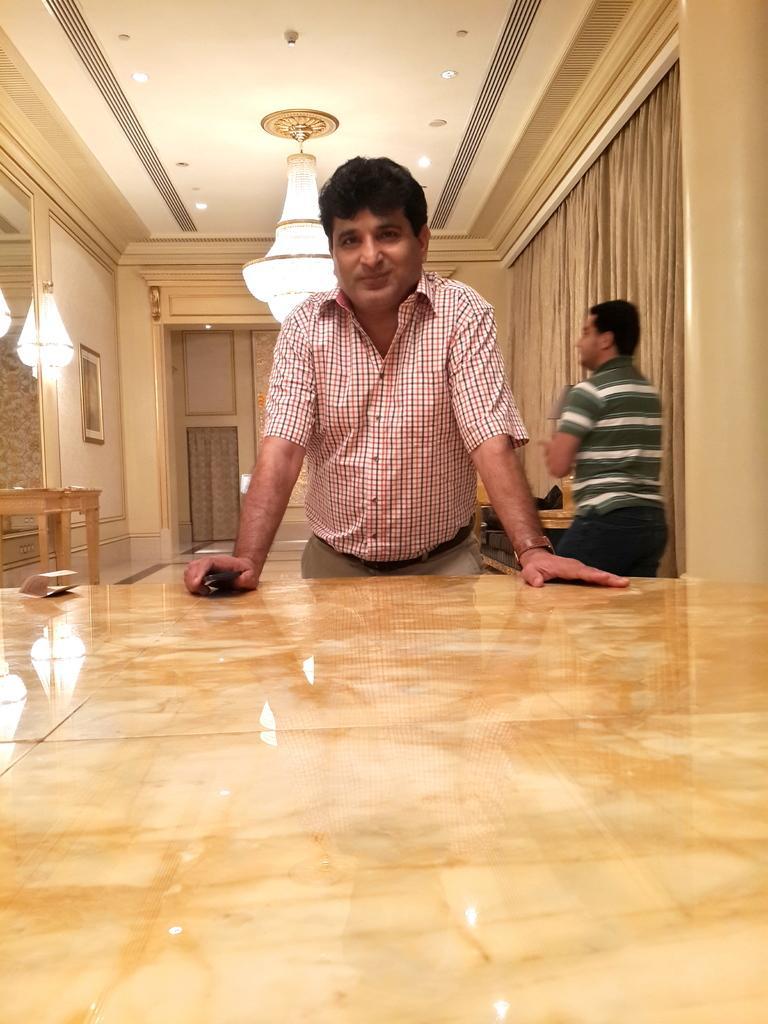Please provide a concise description of this image. In the image two persons are standing behind him there is a roof and lights and there is a wall on the wall there is a frame. In front of him there is a table. 